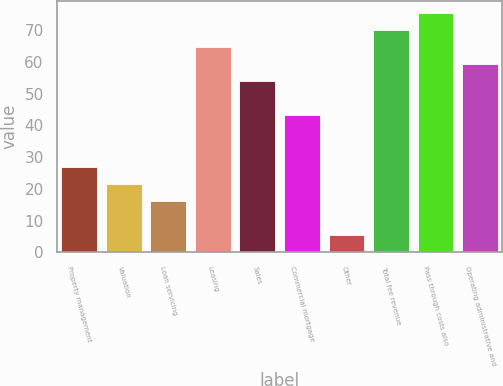<chart> <loc_0><loc_0><loc_500><loc_500><bar_chart><fcel>Property management<fcel>Valuation<fcel>Loan servicing<fcel>Leasing<fcel>Sales<fcel>Commercial mortgage<fcel>Other<fcel>Total fee revenue<fcel>Pass through costs also<fcel>Operating administrative and<nl><fcel>27<fcel>21.62<fcel>16.24<fcel>64.66<fcel>53.9<fcel>43.14<fcel>5.48<fcel>70.04<fcel>75.42<fcel>59.28<nl></chart> 